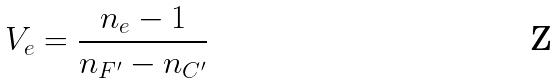<formula> <loc_0><loc_0><loc_500><loc_500>V _ { e } = \frac { n _ { e } - 1 } { n _ { F ^ { \prime } } - n _ { C ^ { \prime } } }</formula> 